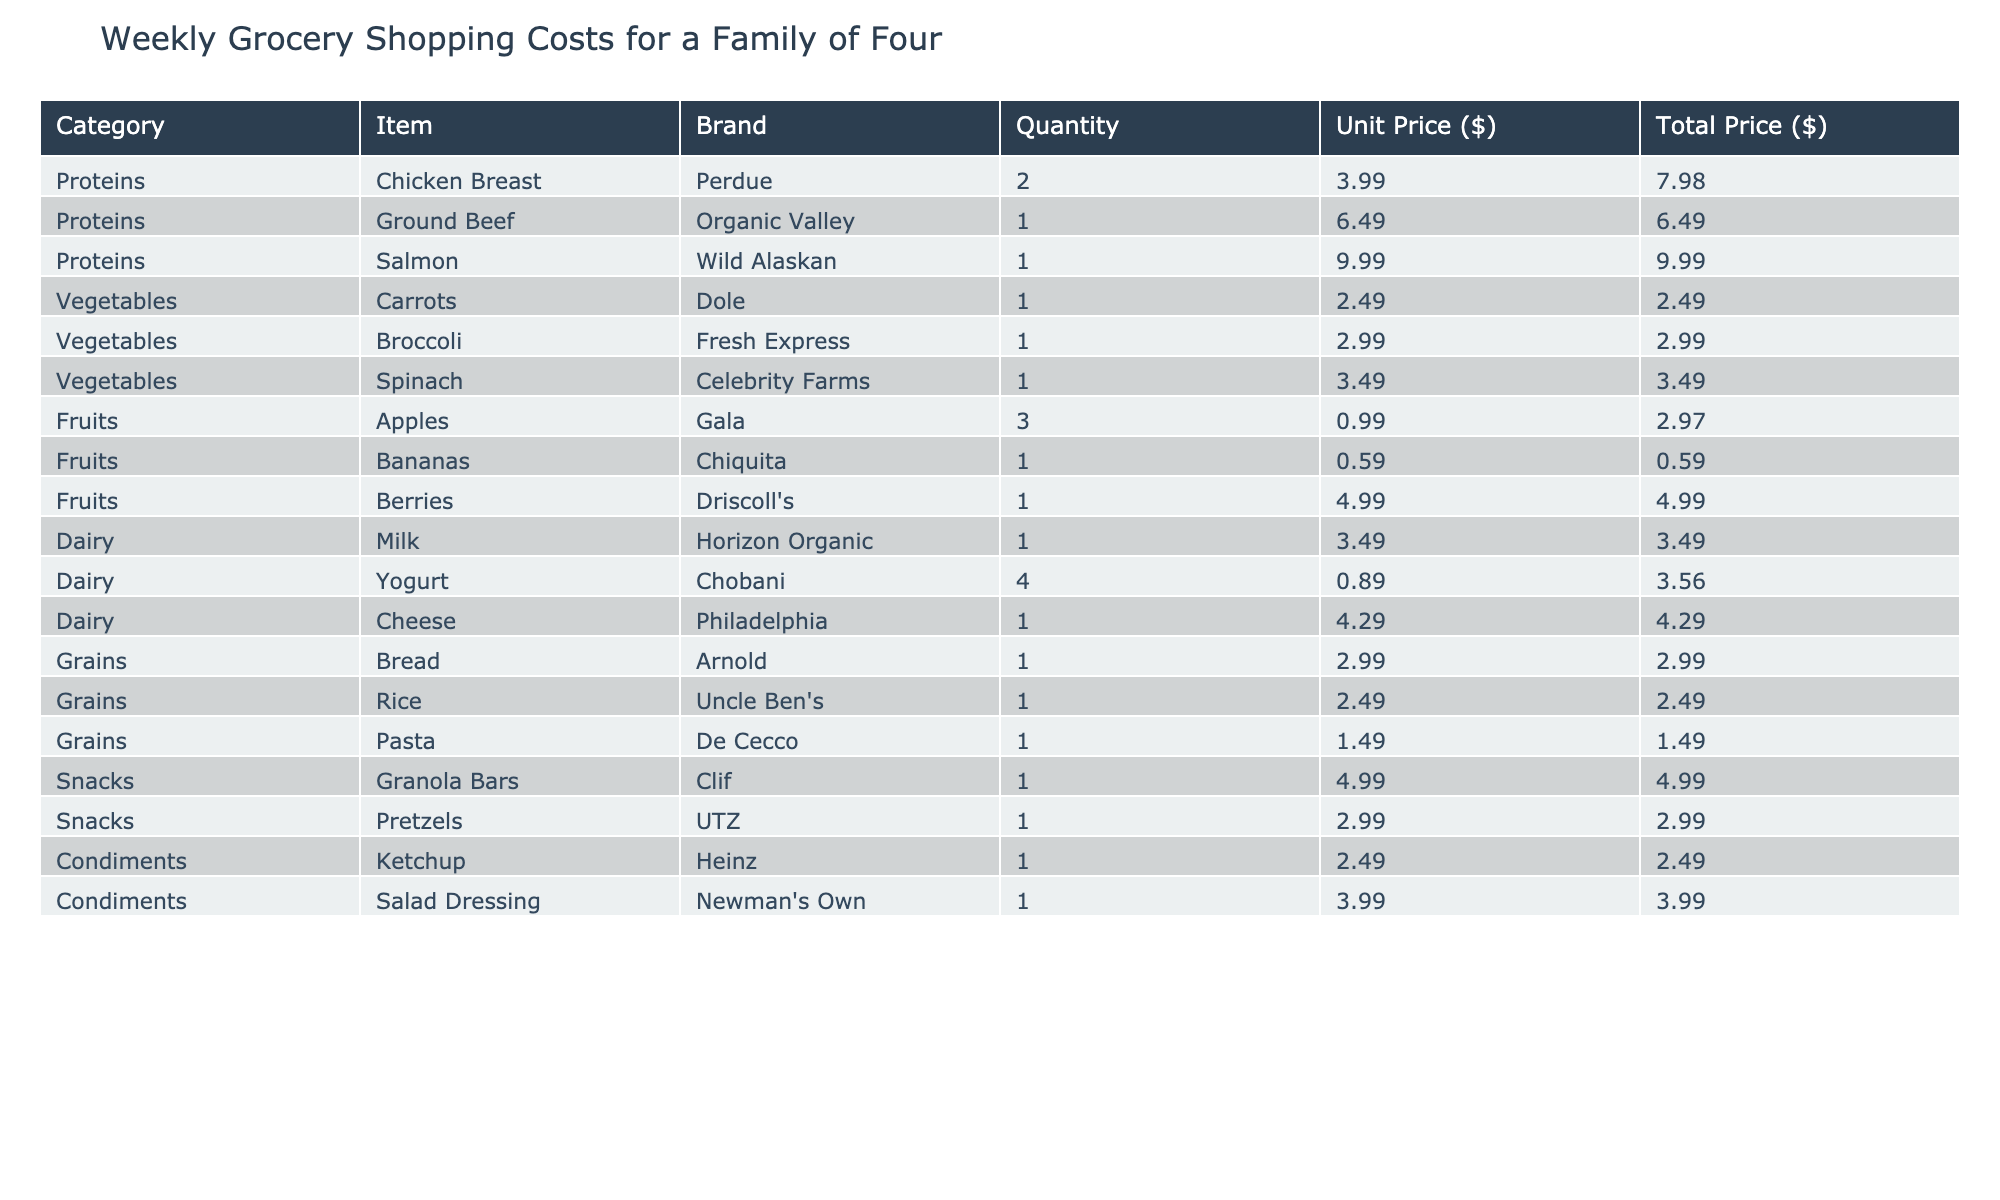What is the total price for Snacks? To find the total price for Snacks, I will add up the Total Price column values that fall under the Snacks category: Granola Bars ($4.99) + Pretzels ($2.99) = $7.98.
Answer: 7.98 What is the unit price of Salmon? The unit price of Salmon as listed under the Proteins category is $9.99.
Answer: 9.99 Is the unit price of Organic Ground Beef higher than that of Chicken Breast? The unit price of Organic Ground Beef is $6.49, and the unit price of Chicken Breast is $3.99. Since $6.49 is greater than $3.99, the statement is true.
Answer: Yes What is the total price of all Fruits combined? To find the total price for Fruits, I will sum the Total Price column for Apples ($2.97) + Bananas ($0.59) + Berries ($4.99) = $8.55.
Answer: 8.55 What is the average unit price of Dairy items? First, I identify the unit prices in the Dairy category: Milk ($3.49), Yogurt ($0.89), and Cheese ($4.29). I then calculate the average: (3.49 + 0.89 + 4.29) / 3 = 2.89.
Answer: 2.89 What is the item with the highest unit price? I will compare the unit prices across all categories: Chicken Breast ($3.99), Ground Beef ($6.49), Salmon ($9.99), etc. The highest unit price is for Salmon at $9.99.
Answer: Salmon How much do the Vegetables cost in total? To calculate the total price for Vegetables, I sum the Total Price values: Carrots ($2.49) + Broccoli ($2.99) + Spinach ($3.49) = $8.97.
Answer: 8.97 Are there more items in the Grains category than in Dairy? The Grains category lists 3 items (Bread, Rice, Pasta) while the Dairy category lists 3 items (Milk, Yogurt, Cheese). Since both categories have the same number of items, the answer is no.
Answer: No What is the combined total price of Proteins and Dairy? I will sum the Total Prices for Proteins: Chicken Breast ($7.98) + Ground Beef ($6.49) + Salmon ($9.99) = $24.46. And for Dairy: Milk ($3.49) + Yogurt ($3.56) + Cheese ($4.29) = $11.34. Combined total is $24.46 + $11.34 = $35.80.
Answer: 35.80 